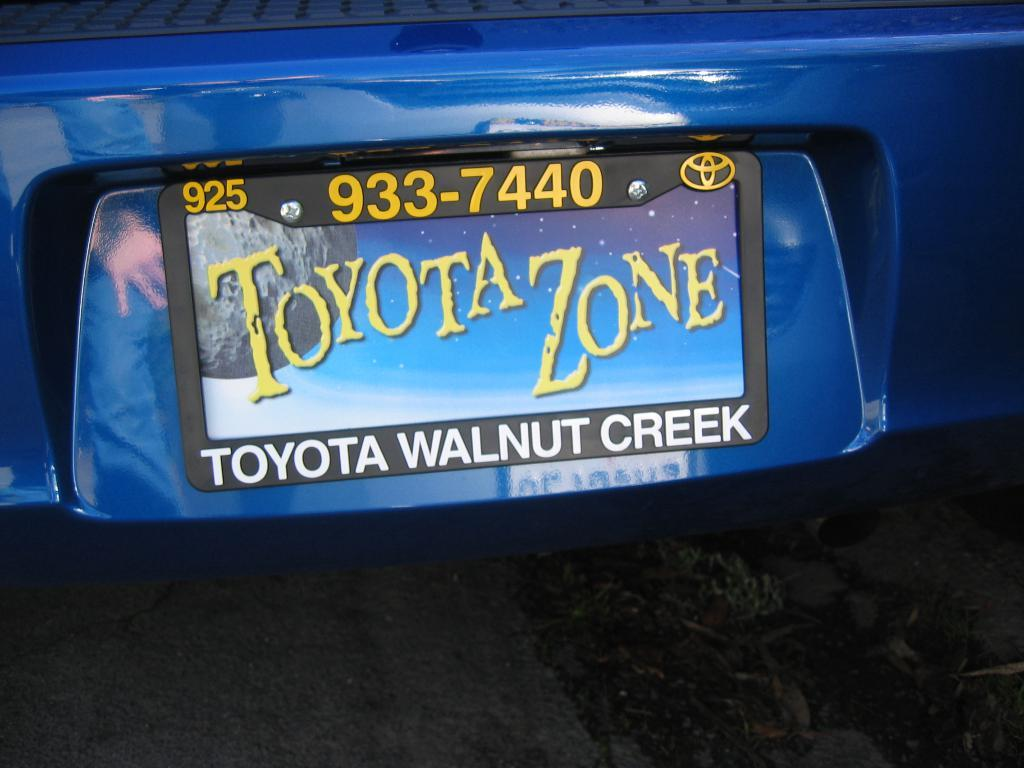<image>
Render a clear and concise summary of the photo. A Toyota dealership in Walnut Creek sells a beautiful art plate. 